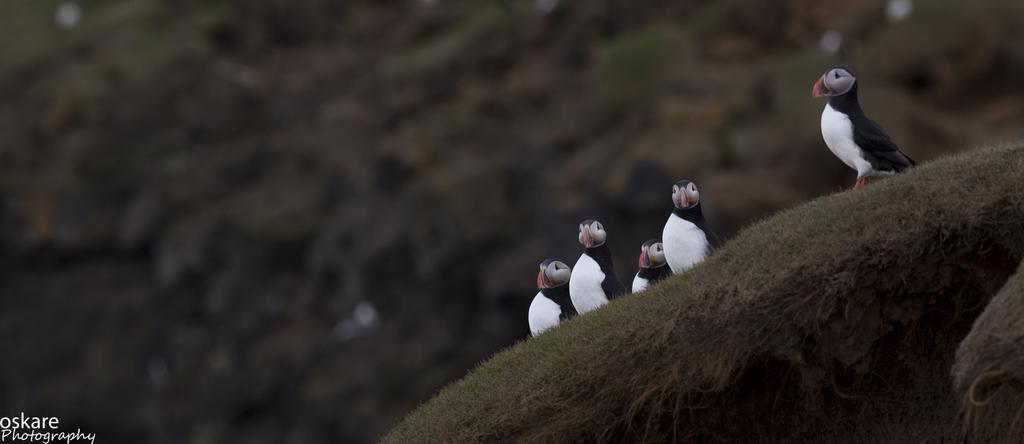What type of vegetation is on the right side of the image? There is grass on the right side of the image. What animals can be seen on the grass? There are birds on the grass. Can you describe the background of the image? The background of the image is blurry. How many tickets are visible in the image? There are no tickets present in the image. What type of fruit can be seen hanging from the grass? There is no fruit hanging from the grass in the image. 